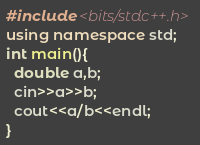Convert code to text. <code><loc_0><loc_0><loc_500><loc_500><_C++_>#include <bits/stdc++.h>
using namespace std;
int main(){ 
  double a,b;
  cin>>a>>b;
  cout<<a/b<<endl;
}
</code> 